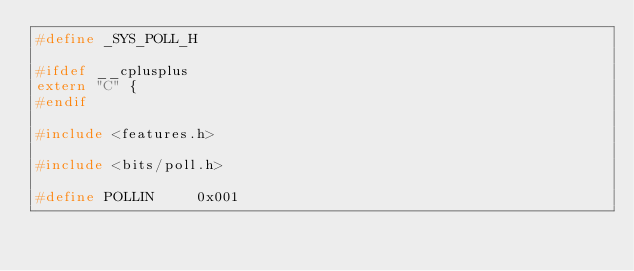<code> <loc_0><loc_0><loc_500><loc_500><_C_>#define	_SYS_POLL_H

#ifdef __cplusplus
extern "C" {
#endif

#include <features.h>

#include <bits/poll.h>

#define POLLIN     0x001</code> 